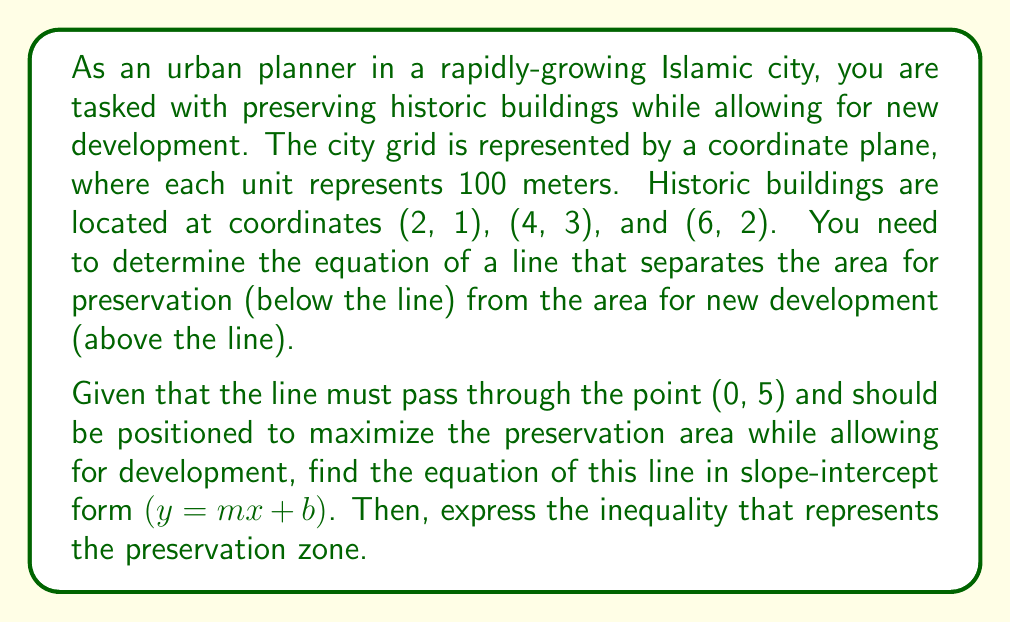Provide a solution to this math problem. Let's approach this step-by-step:

1) We know the line passes through (0, 5), so our y-intercept (b) is 5.

2) We need to find the slope (m) that will create a line above all historic buildings while minimizing the area above the line.

3) Let's calculate the slopes between (0, 5) and each historic building:
   For (2, 1): $m_1 = \frac{1-5}{2-0} = -2$
   For (4, 3): $m_2 = \frac{3-5}{4-0} = -0.5$
   For (6, 2): $m_3 = \frac{2-5}{6-0} = -0.5$

4) The largest (least negative) slope is -0.5. This will create a line just above all historic buildings.

5) Therefore, our line equation is:
   $y = -0.5x + 5$

6) To represent the preservation zone, we use an inequality. Since we want to preserve the area below the line, we use:
   $y \leq -0.5x + 5$

This inequality ensures that all points in the preservation zone are either on or below the line.
Answer: The equation of the line: $y = -0.5x + 5$
The inequality representing the preservation zone: $y \leq -0.5x + 5$ 